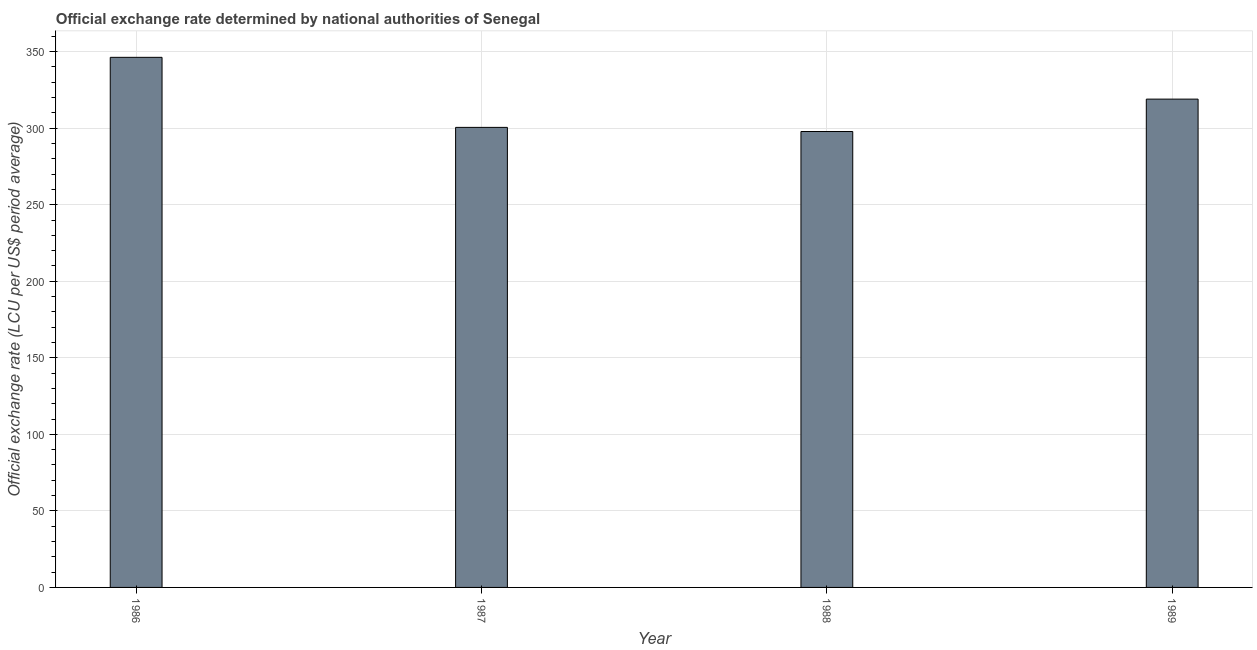Does the graph contain grids?
Your response must be concise. Yes. What is the title of the graph?
Your answer should be compact. Official exchange rate determined by national authorities of Senegal. What is the label or title of the Y-axis?
Make the answer very short. Official exchange rate (LCU per US$ period average). What is the official exchange rate in 1987?
Your answer should be very brief. 300.54. Across all years, what is the maximum official exchange rate?
Ensure brevity in your answer.  346.31. Across all years, what is the minimum official exchange rate?
Your response must be concise. 297.85. In which year was the official exchange rate minimum?
Offer a terse response. 1988. What is the sum of the official exchange rate?
Offer a very short reply. 1263.7. What is the difference between the official exchange rate in 1987 and 1988?
Ensure brevity in your answer.  2.69. What is the average official exchange rate per year?
Offer a very short reply. 315.93. What is the median official exchange rate?
Keep it short and to the point. 309.77. Do a majority of the years between 1987 and 1988 (inclusive) have official exchange rate greater than 130 ?
Make the answer very short. Yes. What is the ratio of the official exchange rate in 1987 to that in 1989?
Provide a short and direct response. 0.94. Is the difference between the official exchange rate in 1987 and 1988 greater than the difference between any two years?
Offer a very short reply. No. What is the difference between the highest and the second highest official exchange rate?
Provide a succinct answer. 27.3. What is the difference between the highest and the lowest official exchange rate?
Your answer should be compact. 48.46. In how many years, is the official exchange rate greater than the average official exchange rate taken over all years?
Provide a short and direct response. 2. How many bars are there?
Your answer should be very brief. 4. How many years are there in the graph?
Your answer should be compact. 4. What is the difference between two consecutive major ticks on the Y-axis?
Ensure brevity in your answer.  50. Are the values on the major ticks of Y-axis written in scientific E-notation?
Make the answer very short. No. What is the Official exchange rate (LCU per US$ period average) in 1986?
Offer a terse response. 346.31. What is the Official exchange rate (LCU per US$ period average) of 1987?
Provide a succinct answer. 300.54. What is the Official exchange rate (LCU per US$ period average) of 1988?
Provide a short and direct response. 297.85. What is the Official exchange rate (LCU per US$ period average) in 1989?
Keep it short and to the point. 319.01. What is the difference between the Official exchange rate (LCU per US$ period average) in 1986 and 1987?
Offer a terse response. 45.77. What is the difference between the Official exchange rate (LCU per US$ period average) in 1986 and 1988?
Offer a terse response. 48.46. What is the difference between the Official exchange rate (LCU per US$ period average) in 1986 and 1989?
Ensure brevity in your answer.  27.3. What is the difference between the Official exchange rate (LCU per US$ period average) in 1987 and 1988?
Give a very brief answer. 2.69. What is the difference between the Official exchange rate (LCU per US$ period average) in 1987 and 1989?
Keep it short and to the point. -18.47. What is the difference between the Official exchange rate (LCU per US$ period average) in 1988 and 1989?
Offer a very short reply. -21.16. What is the ratio of the Official exchange rate (LCU per US$ period average) in 1986 to that in 1987?
Your answer should be very brief. 1.15. What is the ratio of the Official exchange rate (LCU per US$ period average) in 1986 to that in 1988?
Offer a terse response. 1.16. What is the ratio of the Official exchange rate (LCU per US$ period average) in 1986 to that in 1989?
Keep it short and to the point. 1.09. What is the ratio of the Official exchange rate (LCU per US$ period average) in 1987 to that in 1989?
Make the answer very short. 0.94. What is the ratio of the Official exchange rate (LCU per US$ period average) in 1988 to that in 1989?
Give a very brief answer. 0.93. 